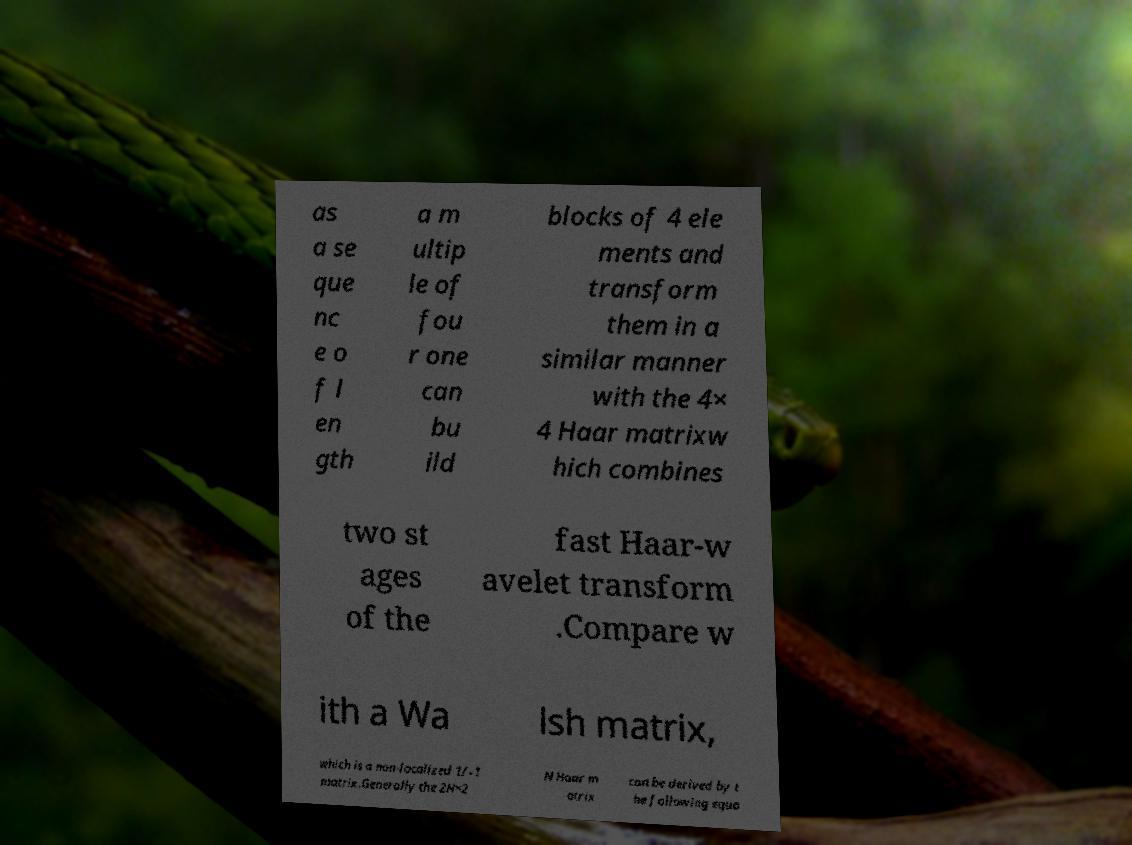Can you accurately transcribe the text from the provided image for me? as a se que nc e o f l en gth a m ultip le of fou r one can bu ild blocks of 4 ele ments and transform them in a similar manner with the 4× 4 Haar matrixw hich combines two st ages of the fast Haar-w avelet transform .Compare w ith a Wa lsh matrix, which is a non-localized 1/–1 matrix.Generally the 2N×2 N Haar m atrix can be derived by t he following equa 